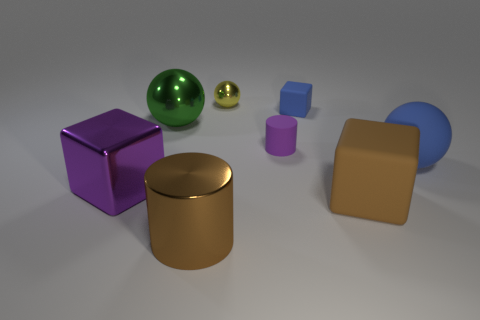Is there a pattern to the arrangement of the objects in this image? While there isn't a clear pattern to how the objects are arranged, they are spaced out in a way that doesn't seem random. They appear carefully placed to showcase their differences in shape, size, and texture, potentially for a visual demonstration or an artistic composition. 